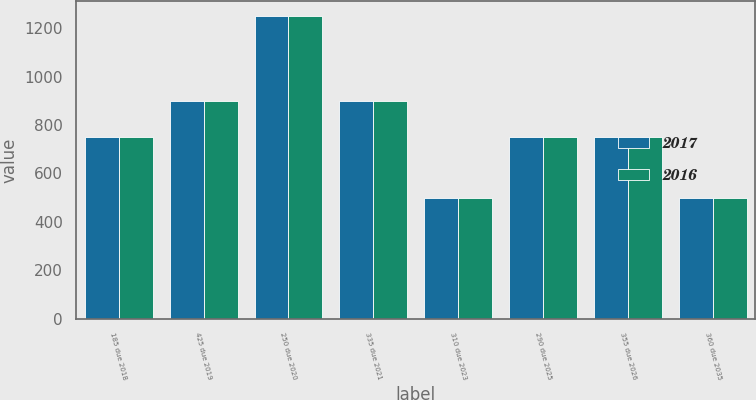<chart> <loc_0><loc_0><loc_500><loc_500><stacked_bar_chart><ecel><fcel>185 due 2018<fcel>425 due 2019<fcel>250 due 2020<fcel>335 due 2021<fcel>310 due 2023<fcel>290 due 2025<fcel>355 due 2026<fcel>360 due 2035<nl><fcel>2017<fcel>750<fcel>900<fcel>1250<fcel>900<fcel>500<fcel>750<fcel>750<fcel>500<nl><fcel>2016<fcel>750<fcel>900<fcel>1250<fcel>900<fcel>500<fcel>750<fcel>750<fcel>500<nl></chart> 